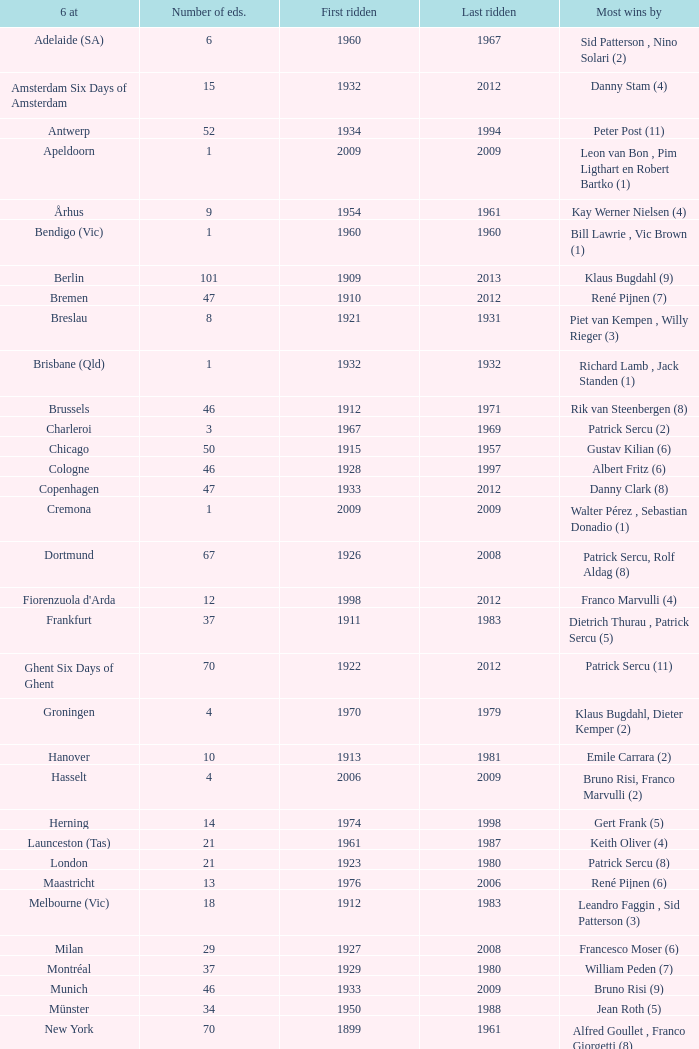How many editions have a most wins value of Franco Marvulli (4)? 1.0. 